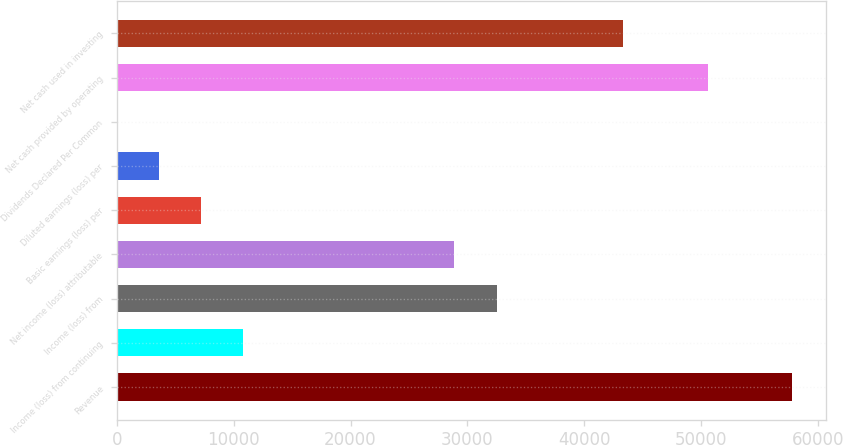Convert chart. <chart><loc_0><loc_0><loc_500><loc_500><bar_chart><fcel>Revenue<fcel>Income (loss) from continuing<fcel>Income (loss) from<fcel>Net income (loss) attributable<fcel>Basic earnings (loss) per<fcel>Diluted earnings (loss) per<fcel>Dividends Declared Per Common<fcel>Net cash provided by operating<fcel>Net cash used in investing<nl><fcel>57790.2<fcel>10836<fcel>32507.2<fcel>28895.3<fcel>7224.17<fcel>3612.31<fcel>0.45<fcel>50566.5<fcel>43342.8<nl></chart> 